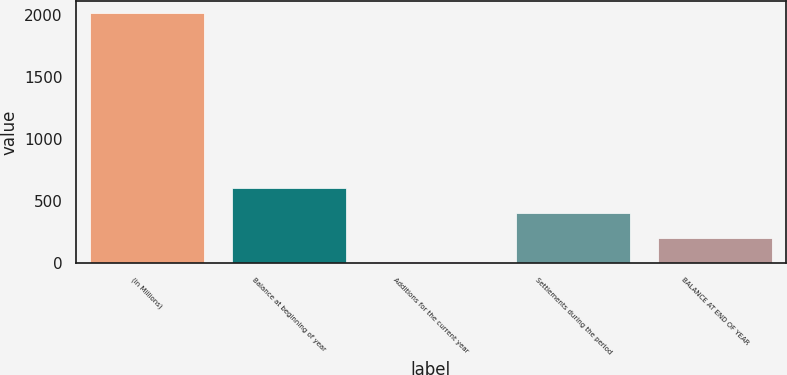Convert chart to OTSL. <chart><loc_0><loc_0><loc_500><loc_500><bar_chart><fcel>(in Millions)<fcel>Balance at beginning of year<fcel>Additions for the current year<fcel>Settlements during the period<fcel>BALANCE AT END OF YEAR<nl><fcel>2011<fcel>606.73<fcel>4.9<fcel>406.12<fcel>205.51<nl></chart> 